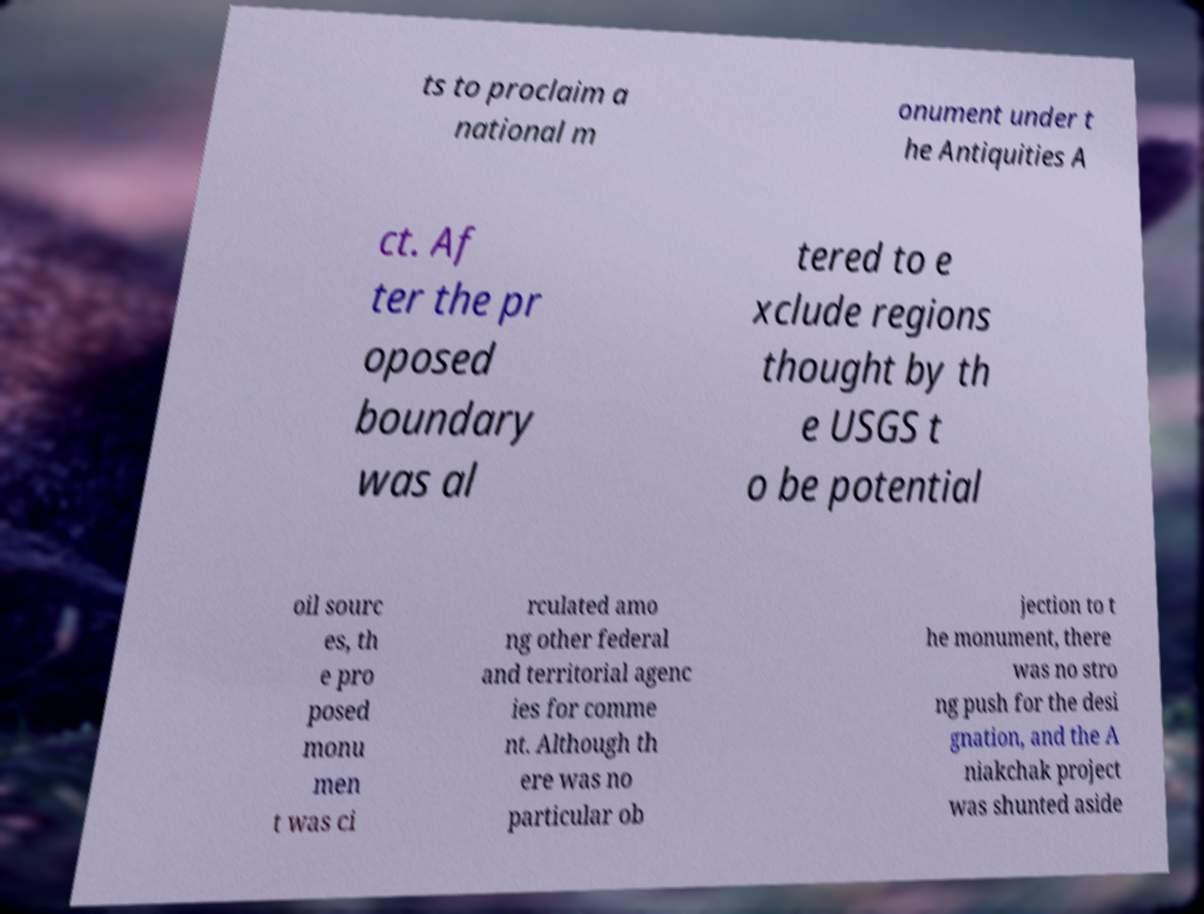I need the written content from this picture converted into text. Can you do that? ts to proclaim a national m onument under t he Antiquities A ct. Af ter the pr oposed boundary was al tered to e xclude regions thought by th e USGS t o be potential oil sourc es, th e pro posed monu men t was ci rculated amo ng other federal and territorial agenc ies for comme nt. Although th ere was no particular ob jection to t he monument, there was no stro ng push for the desi gnation, and the A niakchak project was shunted aside 